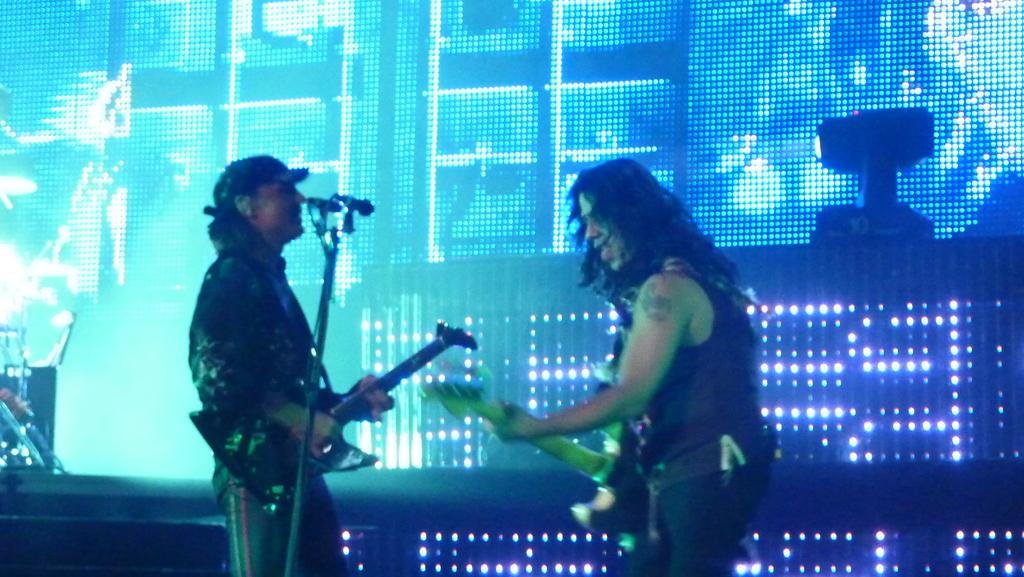How many people are in the image? There are two people in the image. What are the people doing in the image? The people are playing musical instruments. Can you describe any equipment related to sound in the image? Yes, there is a microphone (mike) in the image. What can be seen in the background of the image? There is a screen in the background of the image. What type of breakfast is being prepared on the screen in the background? There is no breakfast or any indication of food preparation on the screen in the background; it is a screen with an unspecified image or content. 